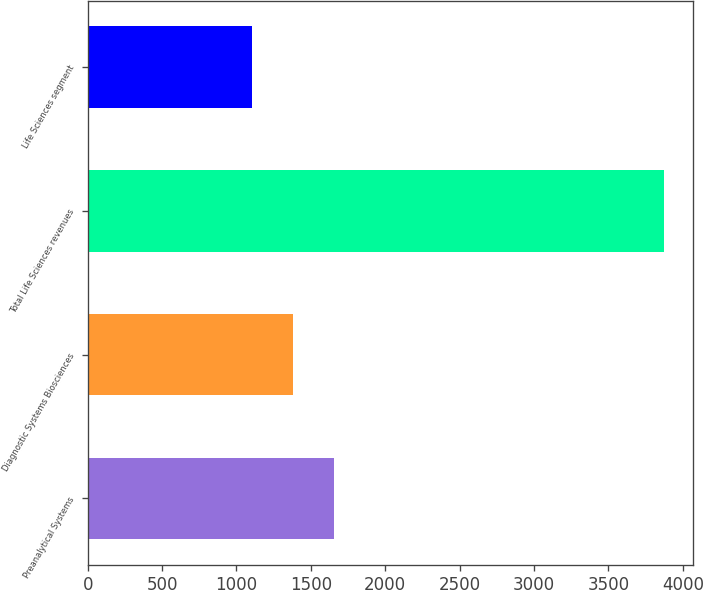Convert chart to OTSL. <chart><loc_0><loc_0><loc_500><loc_500><bar_chart><fcel>Preanalytical Systems<fcel>Diagnostic Systems Biosciences<fcel>Total Life Sciences revenues<fcel>Life Sciences segment<nl><fcel>1657.6<fcel>1380.8<fcel>3872<fcel>1104<nl></chart> 